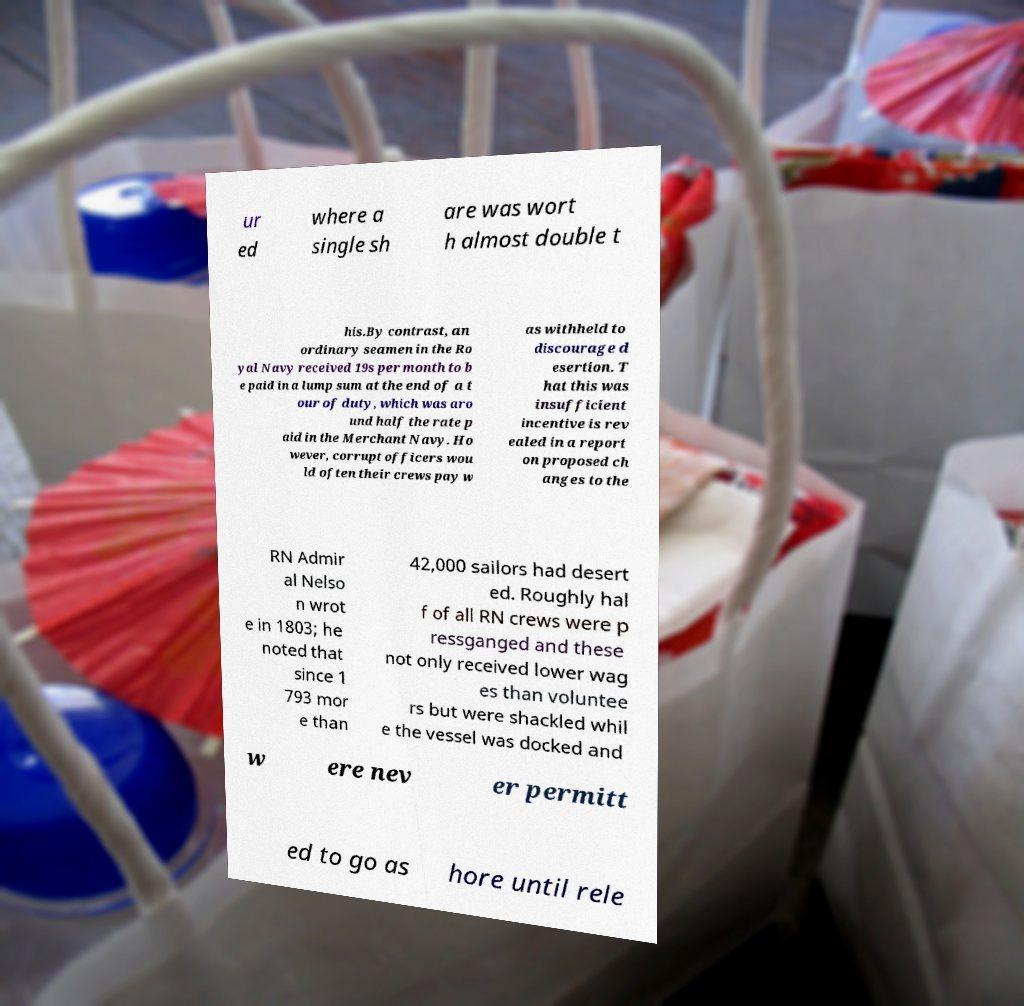Could you extract and type out the text from this image? ur ed where a single sh are was wort h almost double t his.By contrast, an ordinary seamen in the Ro yal Navy received 19s per month to b e paid in a lump sum at the end of a t our of duty, which was aro und half the rate p aid in the Merchant Navy. Ho wever, corrupt officers wou ld often their crews pay w as withheld to discourage d esertion. T hat this was insufficient incentive is rev ealed in a report on proposed ch anges to the RN Admir al Nelso n wrot e in 1803; he noted that since 1 793 mor e than 42,000 sailors had desert ed. Roughly hal f of all RN crews were p ressganged and these not only received lower wag es than voluntee rs but were shackled whil e the vessel was docked and w ere nev er permitt ed to go as hore until rele 